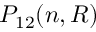Convert formula to latex. <formula><loc_0><loc_0><loc_500><loc_500>P _ { 1 2 } ( n , R )</formula> 